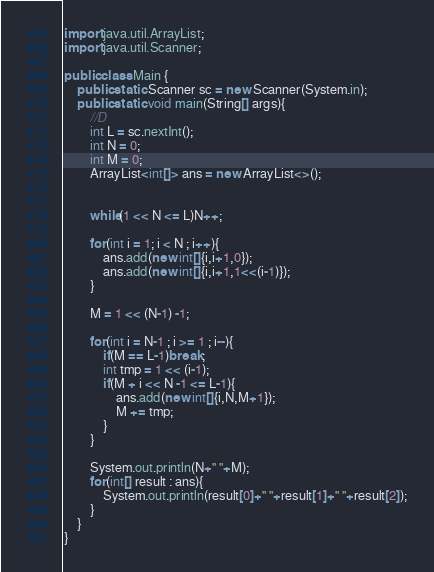Convert code to text. <code><loc_0><loc_0><loc_500><loc_500><_Java_>import java.util.ArrayList;
import java.util.Scanner;

public class Main {
	public static Scanner sc = new Scanner(System.in);
	public static void main(String[] args){
		//D
		int L = sc.nextInt();
		int N = 0;
		int M = 0;
		ArrayList<int[]> ans = new ArrayList<>();


		while(1 << N <= L)N++;

		for(int i = 1; i < N ; i++){
			ans.add(new int[]{i,i+1,0});
			ans.add(new int[]{i,i+1,1<<(i-1)});
		}

		M = 1 << (N-1) -1;

		for(int i = N-1 ; i >= 1 ; i--){
			if(M == L-1)break;
			int tmp = 1 << (i-1);
			if(M + i << N -1 <= L-1){
				ans.add(new int[]{i,N,M+1});
				M += tmp;
			}
		}

		System.out.println(N+" "+M);
		for(int[] result : ans){
			System.out.println(result[0]+" "+result[1]+" "+result[2]);
		}
	}
}</code> 